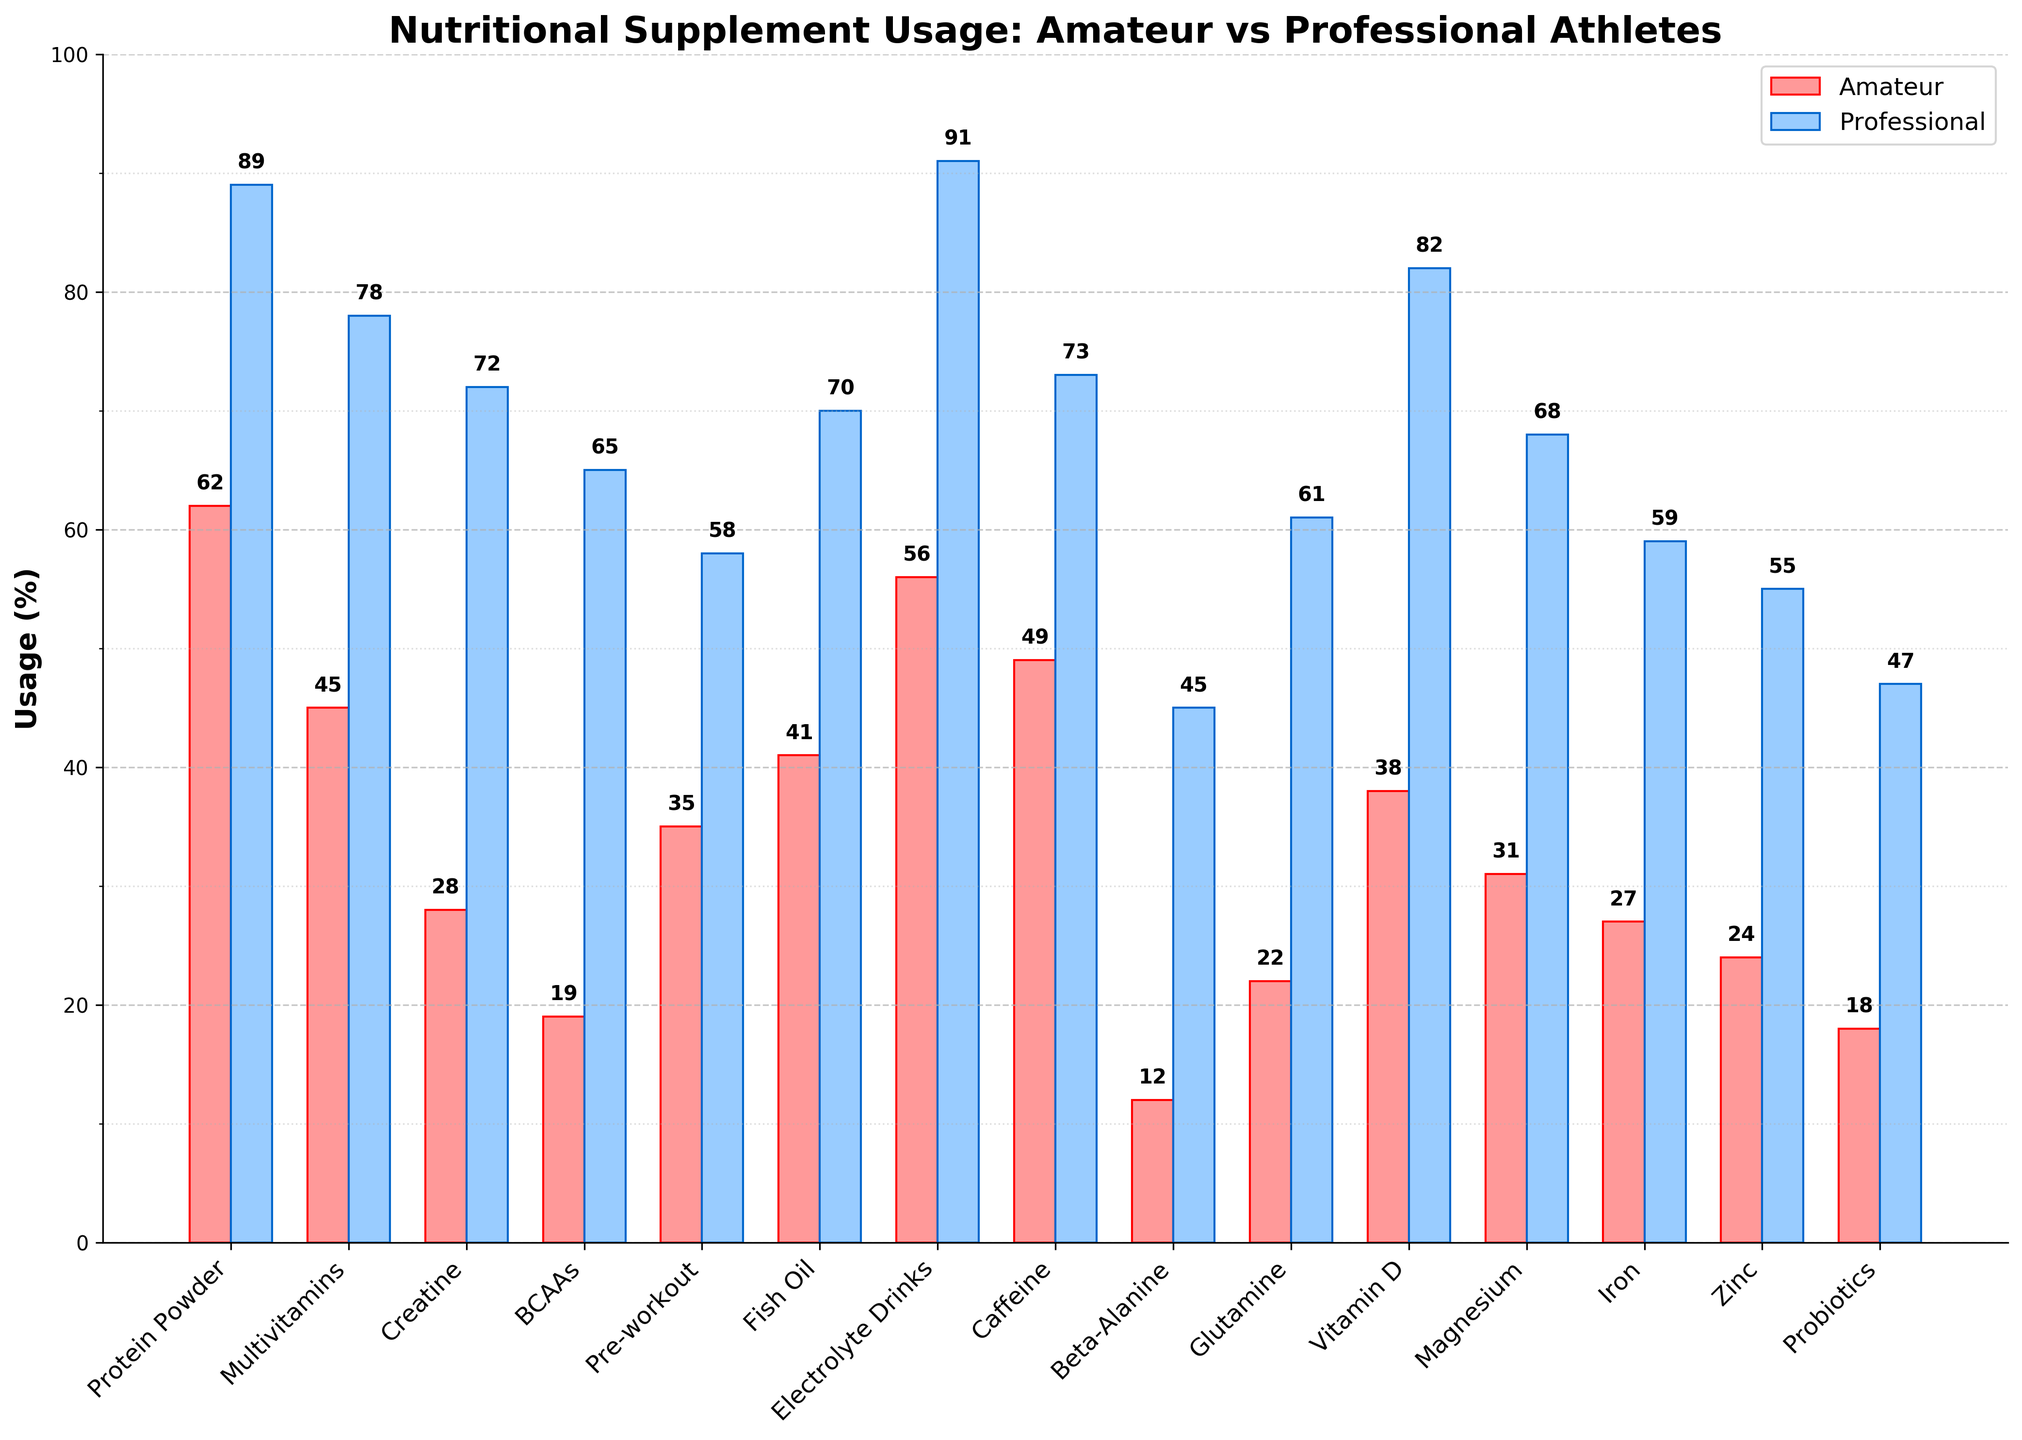Which supplement shows the largest usage difference between amateur and professional athletes? To identify the largest difference, I need to find the absolute differences for each supplement. The differences are: Protein Powder (27), Multivitamins (33), Creatine (44), BCAAs (46), Pre-workout (23), Fish Oil (29), Electrolyte Drinks (35), Caffeine (24), Beta-Alanine (33), Glutamine (39), Vitamin D (44), Magnesium (37), Iron (32), Zinc (31), Probiotics (29). The largest difference is for BCAAs at 46.
Answer: BCAAs Which supplement is used equally by both groups? By examining the height of the bars, it is clear that no supplements are used equally by both amateur and professional athletes.
Answer: None Which supplement has the highest usage among professional athletes? To find the supplement with the highest usage, I look for the tallest blue bar. The highest is Electrolyte Drinks at 91%.
Answer: Electrolyte Drinks What is the total usage percentage of Protein Powder, Multivitamins, and Creatine among professional athletes? Summing the percentages of the mentioned supplements for professional athletes: Protein Powder (89) + Multivitamins (78) + Creatine (72) = 239.
Answer: 239 How much higher is the professional athletes' usage of Glutamine compared to amateur athletes? The usage percentage of Glutamine for professional athletes is 61% and for amateur athletes, it's 22%. The difference is 61 - 22 = 39.
Answer: 39 Which supplement has the smallest usage difference between amateur and professional athletes? To find this, let's calculate the absolute differences: Protein Powder (27), Multivitamins (33), Creatine (44), BCAAs (46), Pre-workout (23), Fish Oil (29), Electrolyte Drinks (35), Caffeine (24), Beta-Alanine (33), Glutamine (39), Vitamin D (44), Magnesium (37), Iron (32), Zinc (31), Probiotics (29). The smallest difference is for Pre-workout at 23.
Answer: Pre-workout Between Magnesium and Iron, which supplement shows a greater difference in usage between amateur and professional athletes? Magnesium shows a difference of 37 (68-31) and Iron shows a difference of 32 (59-27). Therefore, Magnesium has a greater difference.
Answer: Magnesium How many supplements have more than 50% usage among amateur athletes? By examining the bars, the supplements with more than 50% usage among amateur athletes are: Protein Powder (62), Electrolyte Drinks (56). Therefore, there are 2 supplements.
Answer: 2 What is the average usage percentage of Beta-Alanine for both amateur and professional athletes? The usage percentages of Beta-Alanine are 12% for amateur athletes and 45% for professional athletes. The average is (12 + 45) / 2 = 28.5%.
Answer: 28.5 Which supplement shows the greatest proportional increase in usage from amateur to professional athletes? To find the greatest proportional increase, we calculate the ratio of professional to amateur usage for each supplement. For example, Protein Powder: 89/62 ~= 1.435, Multivitamins: 78/45 ~= 1.733. Continuing this calculation, we find that Beta-Alanine shows the greatest increase, with 45/12 = 3.75.
Answer: Beta-Alanine 